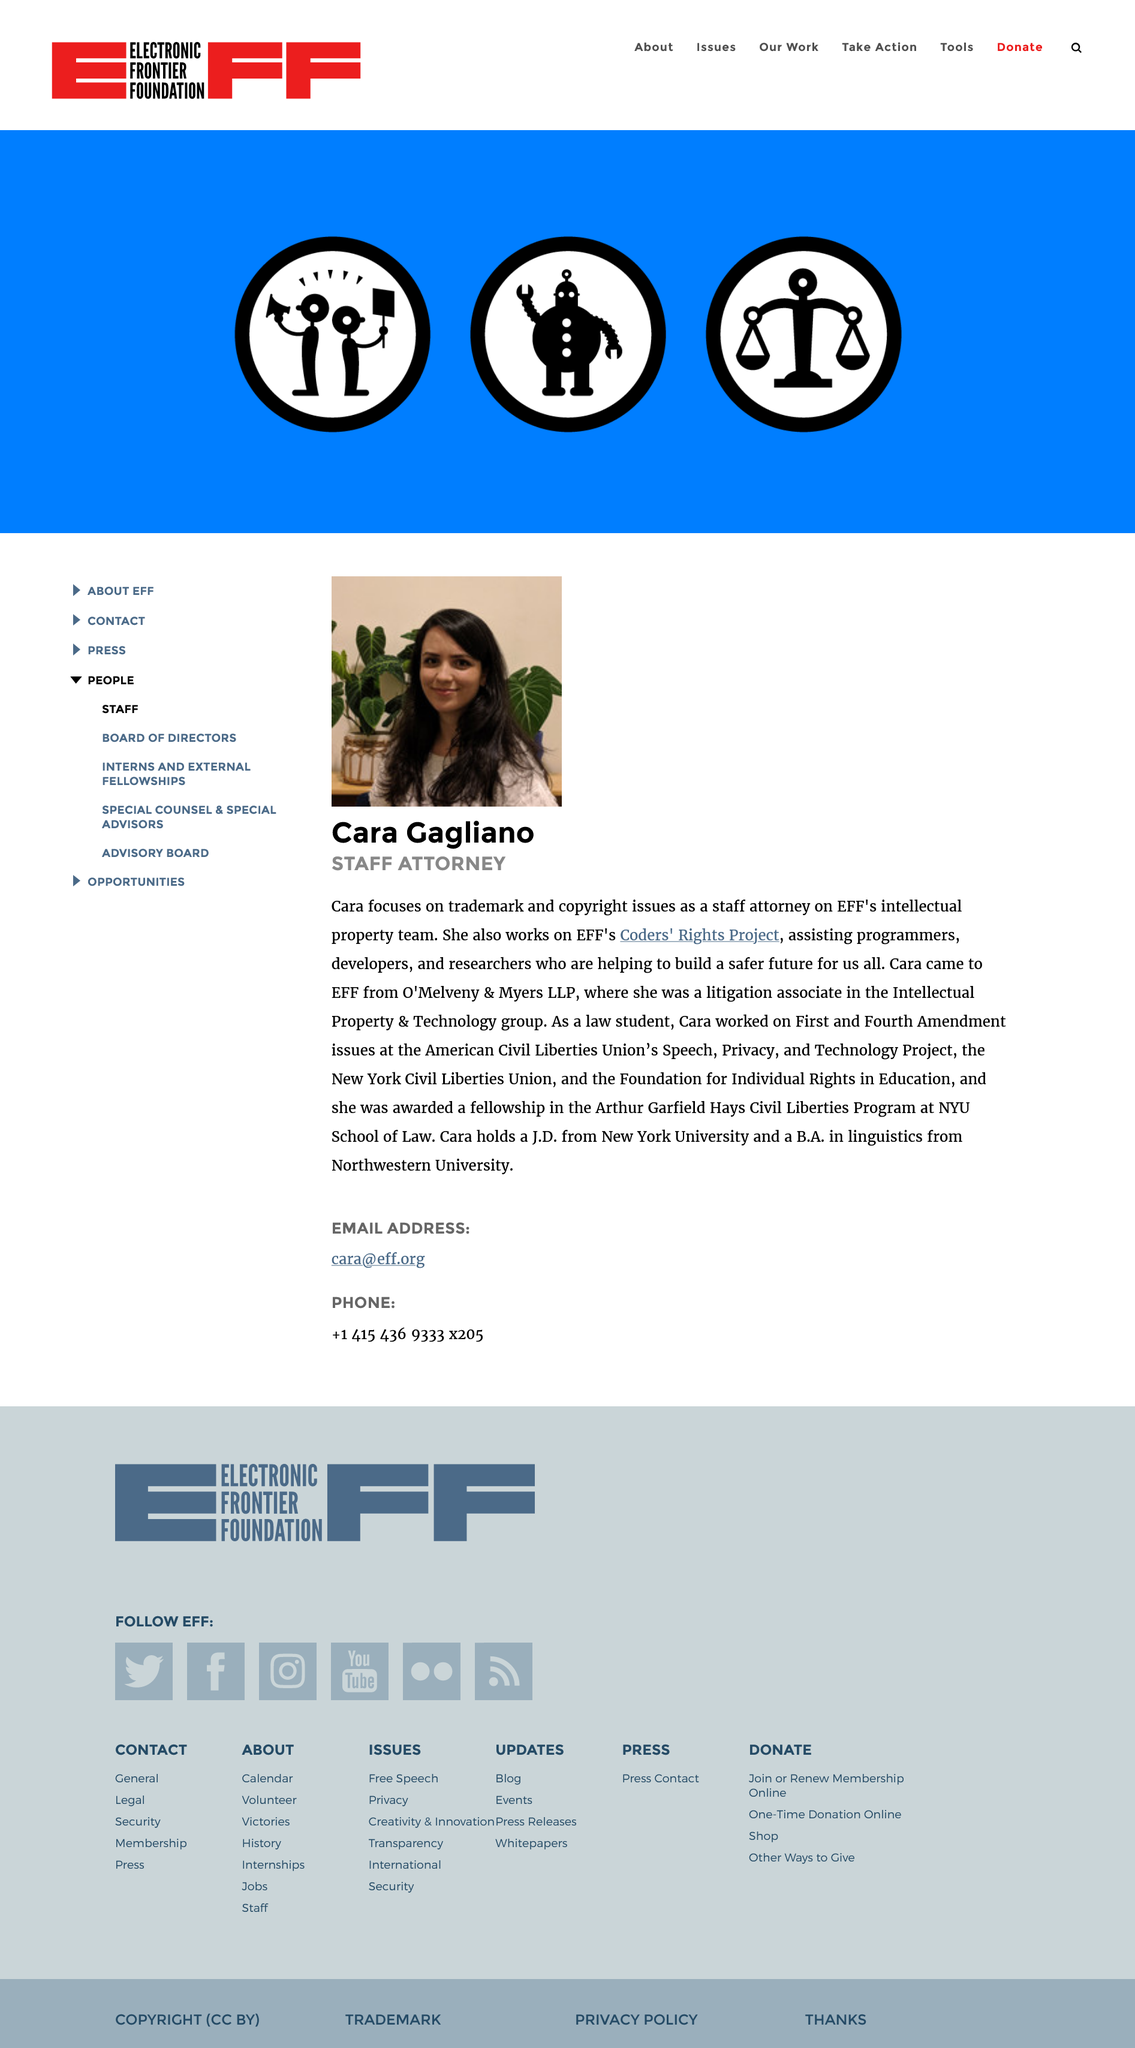List a handful of essential elements in this visual. Cara Gagliano previously worked at O'Melveny & Myers LLP before she joined EFF. Cara Gagliano does not have blonde hair in her photo. Cara Gagliano's job title is staff attorney. 